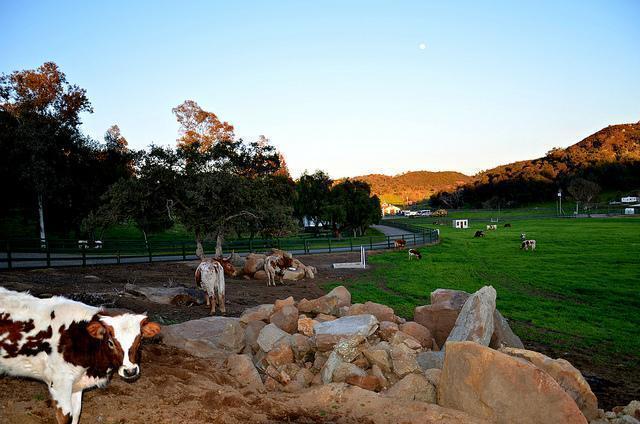What colors are on the cow closest to the camera?
Select the accurate response from the four choices given to answer the question.
Options: Orange, blue, brown white, black. Brown white. 